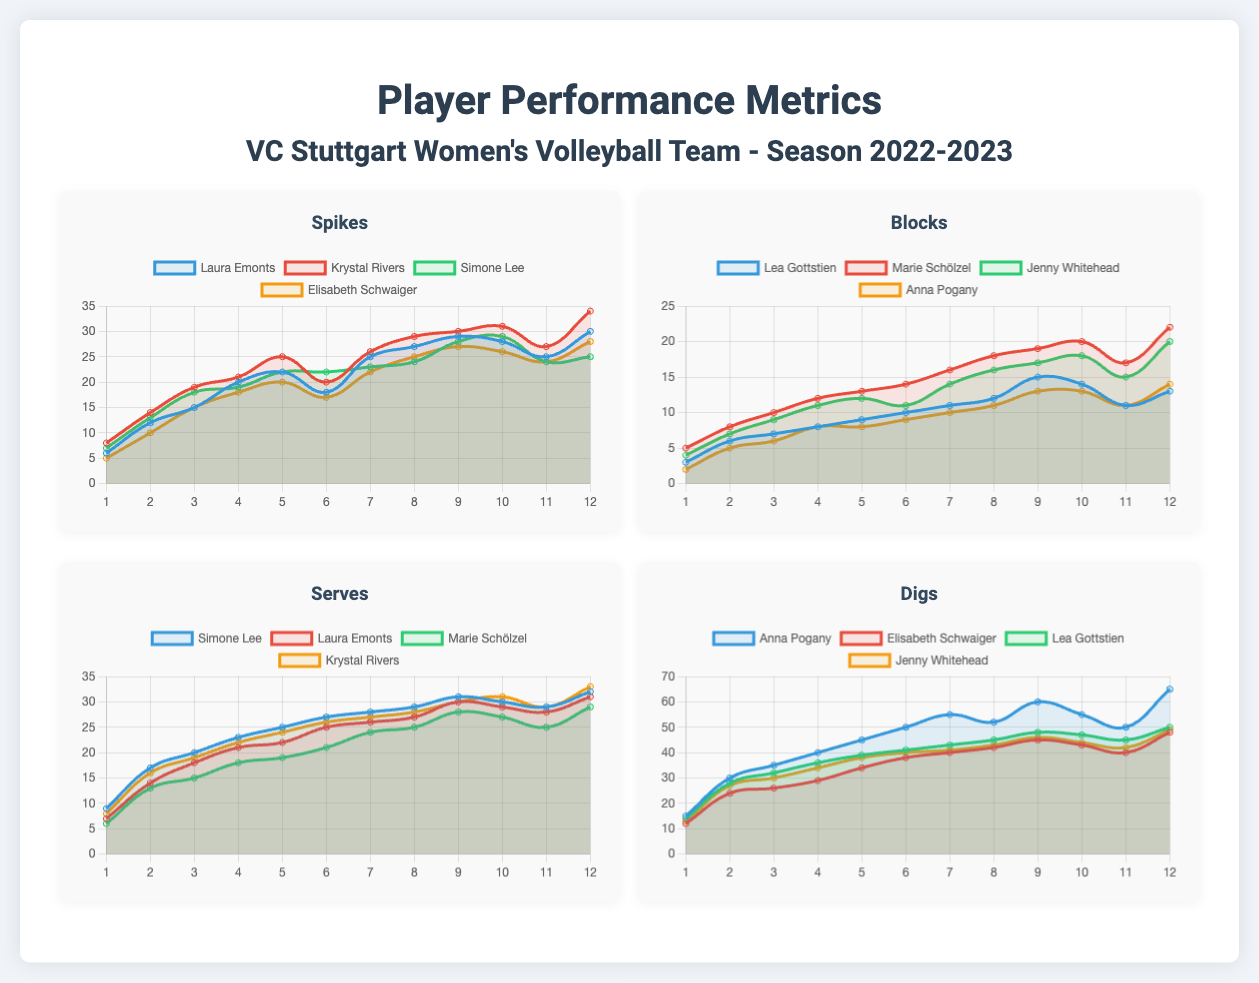What is the total number of spikes made by Krystal Rivers? The total number of spikes made by Krystal Rivers is calculated by summing her performance values across all games, which equals 34.
Answer: 34 Who recorded the highest number of digs in the season? The player with the highest number of digs is Anna Pogany, with a maximum performance of 65 in game 12.
Answer: Anna Pogany What was Laura Emonts' performance in spikes during game 6? Laura Emonts had a performance of 18 spikes in game 6, as indicated in her spikes chart.
Answer: 18 During which game did Marie Schölzel achieve the highest number of blocks? Marie Schölzel achieved the highest number of blocks (22) during game 12, as shown in the blocks chart.
Answer: Game 12 What was the average number of serves completed by Simone Lee over the season? Simone Lee's serves can be averaged by summing her performance and dividing by the number of games, resulting in 24.
Answer: 24 In which metric did Elisabeth Schwaiger have the lowest performance? Elisabeth Schwaiger had the lowest performance in digs, with a score of 12 in game 1.
Answer: Digs Which player had the most consistent performance in blocks? Looking at the performance data, Jenny Whitehead showed consistent results in blocks, with less variance in her scores compared to others.
Answer: Jenny Whitehead What trends can be observed in Krystal Rivers' serves over the season? Krystal Rivers displayed an upward trend in her serving performance, with scores increasing by the end of the season.
Answer: Upward trend 